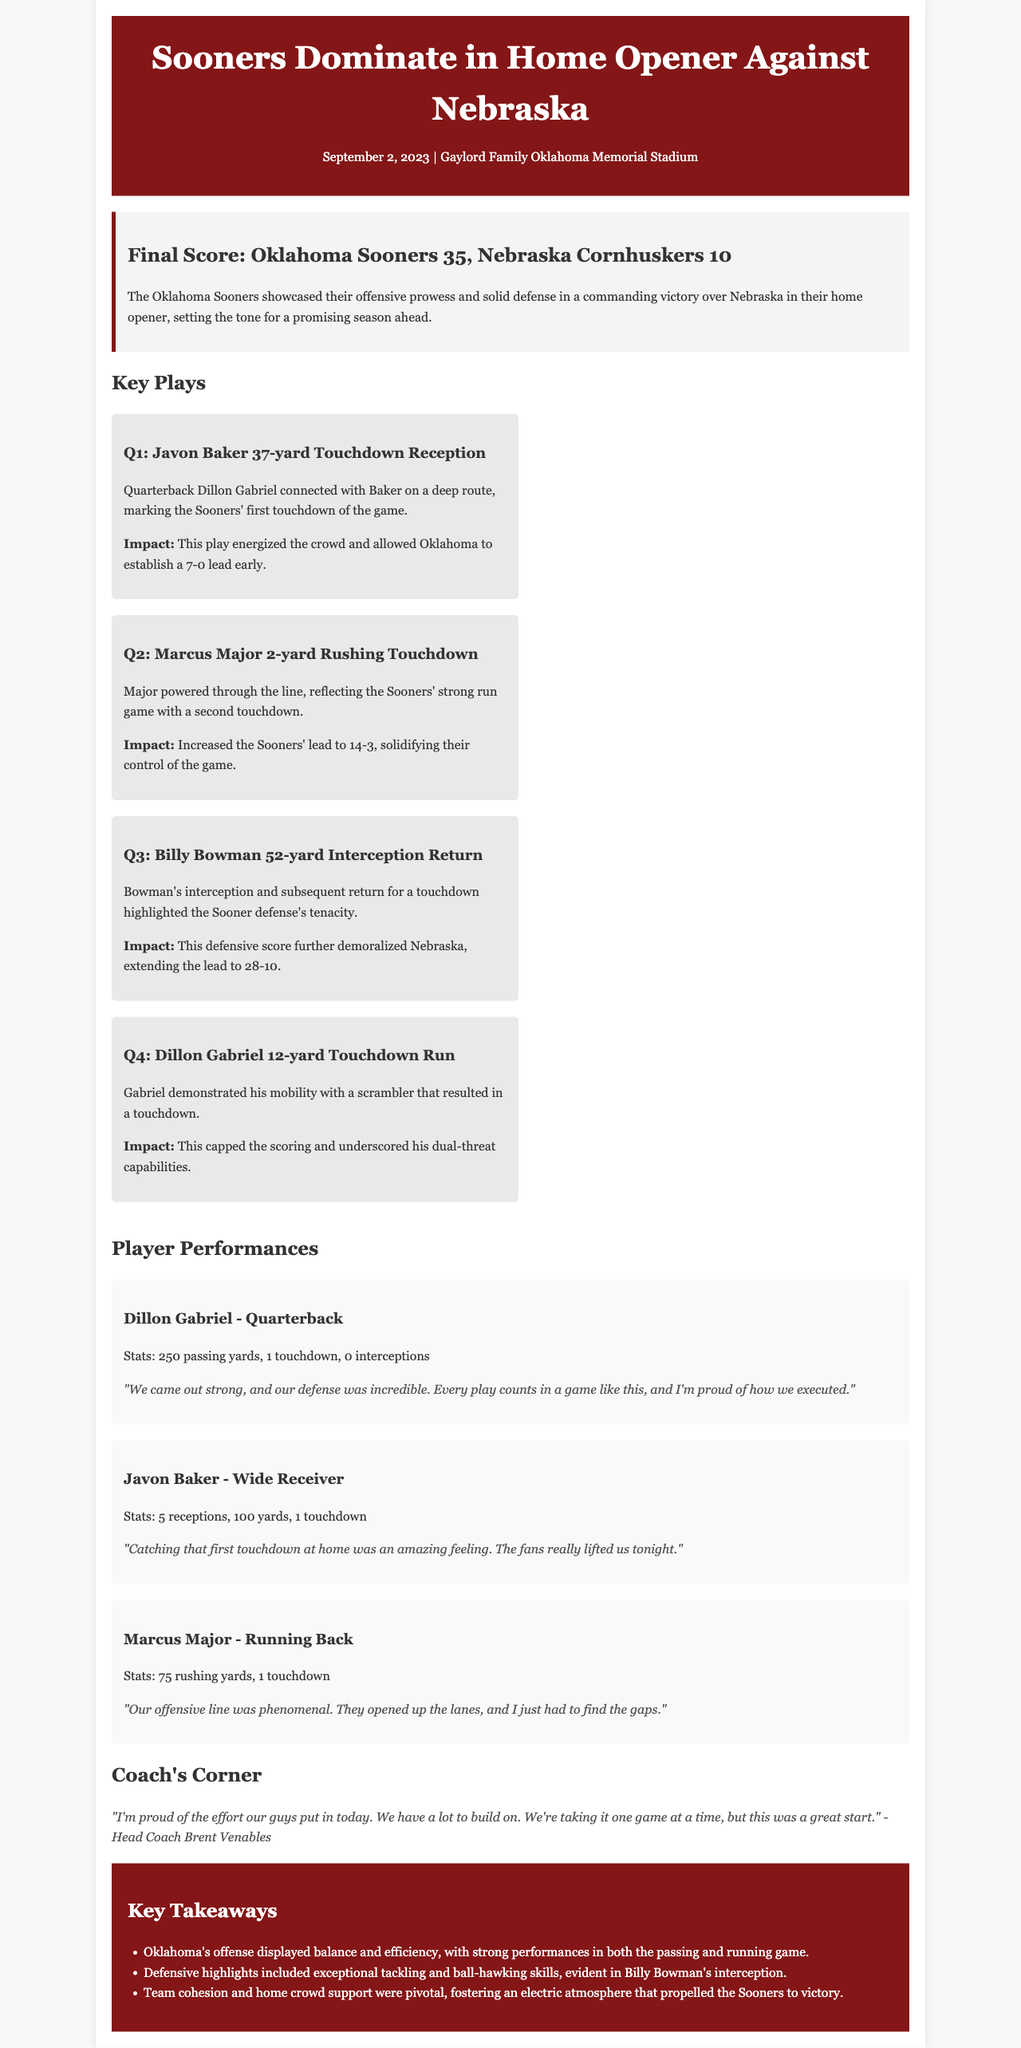What was the final score of the game? The final score is mentioned in the game info section of the document, which states Oklahoma Sooners 35, Nebraska Cornhuskers 10.
Answer: Oklahoma Sooners 35, Nebraska Cornhuskers 10 Who caught the first touchdown of the game? The document states that Javon Baker caught the first touchdown reception in the first quarter.
Answer: Javon Baker What is Dillon Gabriel's passing yard total? This can be found in the Player Performances section under Dillon Gabriel's stats, which indicate 250 passing yards.
Answer: 250 passing yards Which player had a 52-yard interception return? The section on Key Plays highlights Billy Bowman as the player who achieved a 52-yard interception return.
Answer: Billy Bowman How many rushing yards did Marcus Major have? The player performance details for Marcus Major indicate he had 75 rushing yards.
Answer: 75 rushing yards What did Head Coach Brent Venables say about the game? The Coach's Corner section notes Coach Venables' quote about the team's effort and the game.
Answer: "I'm proud of the effort our guys put in today." What was the impact of Javon Baker's touchdown? The document describes that Baker's touchdown energized the crowd and helped Oklahoma establish an early lead.
Answer: Energized the crowd and established a 7-0 lead early What is one key takeaway from the game? The Takeaways section lists several insights, one of which is about Oklahoma's offense displaying balance and efficiency.
Answer: Oklahoma's offense displayed balance and efficiency What was the date of the game? The date of the game is provided in the header of the document as September 2, 2023.
Answer: September 2, 2023 